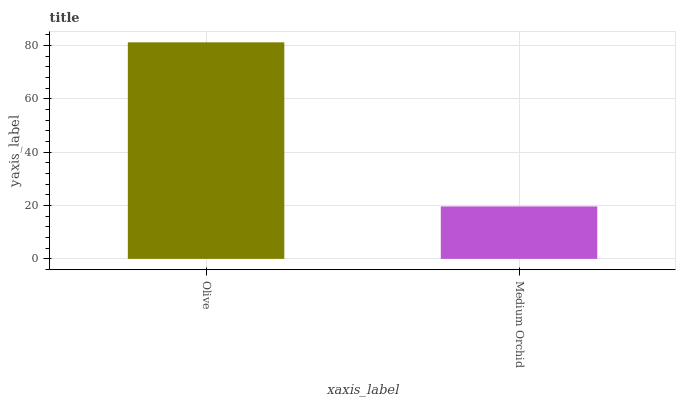Is Medium Orchid the minimum?
Answer yes or no. Yes. Is Olive the maximum?
Answer yes or no. Yes. Is Medium Orchid the maximum?
Answer yes or no. No. Is Olive greater than Medium Orchid?
Answer yes or no. Yes. Is Medium Orchid less than Olive?
Answer yes or no. Yes. Is Medium Orchid greater than Olive?
Answer yes or no. No. Is Olive less than Medium Orchid?
Answer yes or no. No. Is Olive the high median?
Answer yes or no. Yes. Is Medium Orchid the low median?
Answer yes or no. Yes. Is Medium Orchid the high median?
Answer yes or no. No. Is Olive the low median?
Answer yes or no. No. 